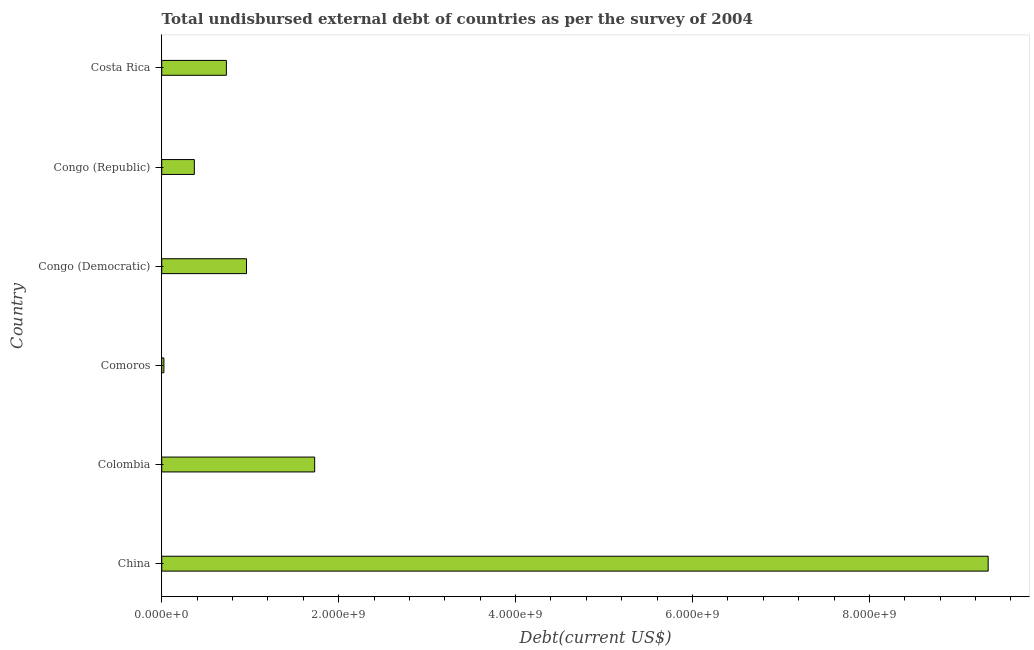What is the title of the graph?
Your response must be concise. Total undisbursed external debt of countries as per the survey of 2004. What is the label or title of the X-axis?
Give a very brief answer. Debt(current US$). What is the total debt in Congo (Democratic)?
Keep it short and to the point. 9.59e+08. Across all countries, what is the maximum total debt?
Ensure brevity in your answer.  9.34e+09. Across all countries, what is the minimum total debt?
Your response must be concise. 2.48e+07. In which country was the total debt minimum?
Offer a very short reply. Comoros. What is the sum of the total debt?
Your response must be concise. 1.32e+1. What is the difference between the total debt in Colombia and Congo (Republic)?
Provide a succinct answer. 1.36e+09. What is the average total debt per country?
Offer a very short reply. 2.19e+09. What is the median total debt?
Offer a very short reply. 8.45e+08. What is the ratio of the total debt in Colombia to that in Congo (Republic)?
Your answer should be very brief. 4.69. Is the difference between the total debt in China and Comoros greater than the difference between any two countries?
Provide a succinct answer. Yes. What is the difference between the highest and the second highest total debt?
Offer a terse response. 7.61e+09. Is the sum of the total debt in Colombia and Congo (Republic) greater than the maximum total debt across all countries?
Provide a short and direct response. No. What is the difference between the highest and the lowest total debt?
Your response must be concise. 9.32e+09. In how many countries, is the total debt greater than the average total debt taken over all countries?
Your response must be concise. 1. Are all the bars in the graph horizontal?
Ensure brevity in your answer.  Yes. How many countries are there in the graph?
Offer a very short reply. 6. What is the difference between two consecutive major ticks on the X-axis?
Your response must be concise. 2.00e+09. What is the Debt(current US$) of China?
Provide a short and direct response. 9.34e+09. What is the Debt(current US$) in Colombia?
Ensure brevity in your answer.  1.73e+09. What is the Debt(current US$) in Comoros?
Provide a short and direct response. 2.48e+07. What is the Debt(current US$) in Congo (Democratic)?
Your answer should be compact. 9.59e+08. What is the Debt(current US$) in Congo (Republic)?
Provide a short and direct response. 3.69e+08. What is the Debt(current US$) of Costa Rica?
Your answer should be very brief. 7.31e+08. What is the difference between the Debt(current US$) in China and Colombia?
Keep it short and to the point. 7.61e+09. What is the difference between the Debt(current US$) in China and Comoros?
Your answer should be compact. 9.32e+09. What is the difference between the Debt(current US$) in China and Congo (Democratic)?
Give a very brief answer. 8.38e+09. What is the difference between the Debt(current US$) in China and Congo (Republic)?
Give a very brief answer. 8.97e+09. What is the difference between the Debt(current US$) in China and Costa Rica?
Your answer should be compact. 8.61e+09. What is the difference between the Debt(current US$) in Colombia and Comoros?
Make the answer very short. 1.70e+09. What is the difference between the Debt(current US$) in Colombia and Congo (Democratic)?
Give a very brief answer. 7.71e+08. What is the difference between the Debt(current US$) in Colombia and Congo (Republic)?
Offer a very short reply. 1.36e+09. What is the difference between the Debt(current US$) in Colombia and Costa Rica?
Offer a terse response. 9.98e+08. What is the difference between the Debt(current US$) in Comoros and Congo (Democratic)?
Provide a short and direct response. -9.34e+08. What is the difference between the Debt(current US$) in Comoros and Congo (Republic)?
Provide a short and direct response. -3.44e+08. What is the difference between the Debt(current US$) in Comoros and Costa Rica?
Give a very brief answer. -7.06e+08. What is the difference between the Debt(current US$) in Congo (Democratic) and Congo (Republic)?
Your answer should be compact. 5.90e+08. What is the difference between the Debt(current US$) in Congo (Democratic) and Costa Rica?
Your answer should be compact. 2.27e+08. What is the difference between the Debt(current US$) in Congo (Republic) and Costa Rica?
Your answer should be very brief. -3.62e+08. What is the ratio of the Debt(current US$) in China to that in Colombia?
Your answer should be very brief. 5.4. What is the ratio of the Debt(current US$) in China to that in Comoros?
Give a very brief answer. 376.33. What is the ratio of the Debt(current US$) in China to that in Congo (Democratic)?
Offer a terse response. 9.75. What is the ratio of the Debt(current US$) in China to that in Congo (Republic)?
Give a very brief answer. 25.34. What is the ratio of the Debt(current US$) in China to that in Costa Rica?
Keep it short and to the point. 12.78. What is the ratio of the Debt(current US$) in Colombia to that in Comoros?
Your response must be concise. 69.65. What is the ratio of the Debt(current US$) in Colombia to that in Congo (Democratic)?
Keep it short and to the point. 1.8. What is the ratio of the Debt(current US$) in Colombia to that in Congo (Republic)?
Offer a very short reply. 4.69. What is the ratio of the Debt(current US$) in Colombia to that in Costa Rica?
Provide a short and direct response. 2.37. What is the ratio of the Debt(current US$) in Comoros to that in Congo (Democratic)?
Provide a short and direct response. 0.03. What is the ratio of the Debt(current US$) in Comoros to that in Congo (Republic)?
Keep it short and to the point. 0.07. What is the ratio of the Debt(current US$) in Comoros to that in Costa Rica?
Your response must be concise. 0.03. What is the ratio of the Debt(current US$) in Congo (Democratic) to that in Congo (Republic)?
Your answer should be compact. 2.6. What is the ratio of the Debt(current US$) in Congo (Democratic) to that in Costa Rica?
Provide a short and direct response. 1.31. What is the ratio of the Debt(current US$) in Congo (Republic) to that in Costa Rica?
Keep it short and to the point. 0.5. 